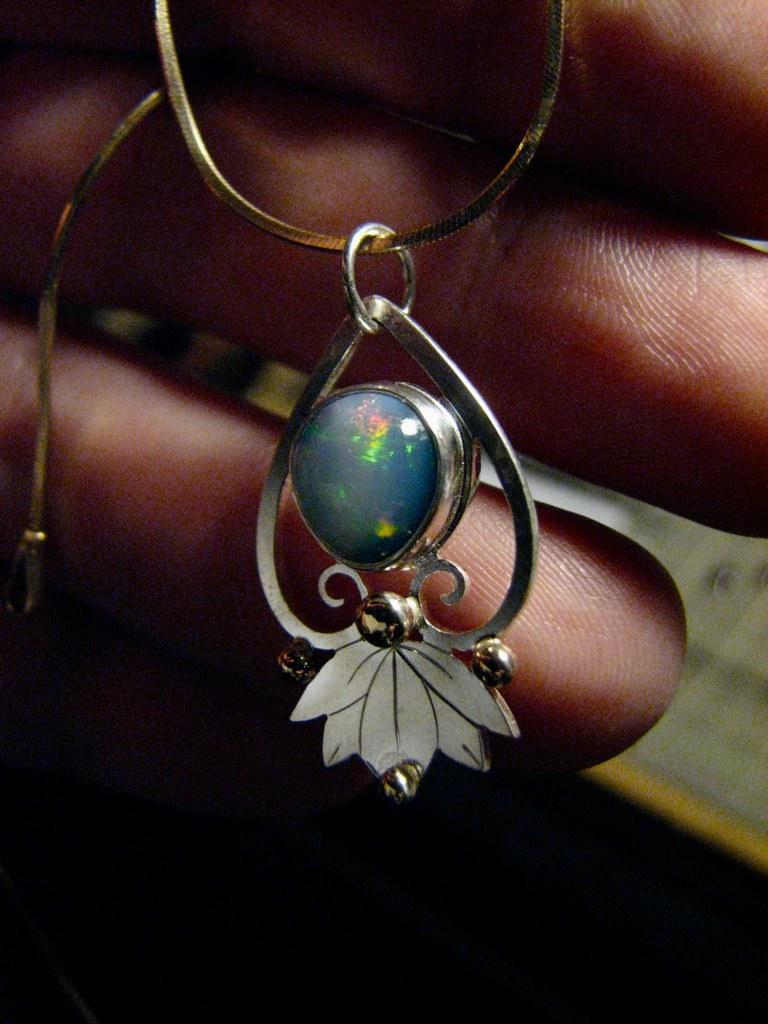What is hanging from the chain in the image? There is a pendant hanging from the chain in the image. Whose fingers are visible in the image? The fingers of a person are visible in the image. What type of collar is the farmer wearing in the image? There is no farmer or collar present in the image. How many beans are visible on the person's fingers in the image? There are no beans visible on the person's fingers in the image. 